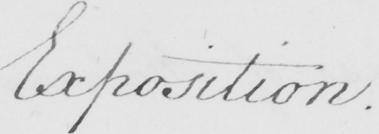What does this handwritten line say? Exposition . 